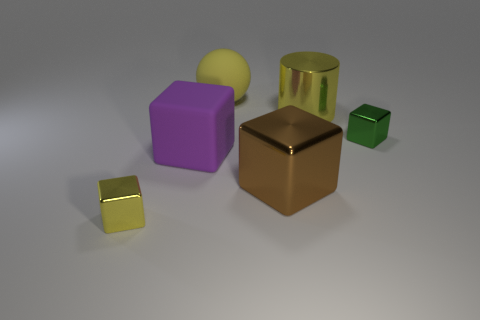What number of things are large yellow things to the right of the yellow ball or rubber objects that are behind the purple block?
Keep it short and to the point. 2. There is a tiny thing on the left side of the big brown metallic thing; does it have the same color as the big shiny cube?
Keep it short and to the point. No. How many other objects are the same color as the rubber sphere?
Provide a short and direct response. 2. What is the brown thing made of?
Offer a very short reply. Metal. There is a shiny thing to the left of the purple cube; does it have the same size as the green thing?
Your response must be concise. Yes. What size is the purple matte object that is the same shape as the brown shiny thing?
Provide a succinct answer. Large. Are there the same number of yellow blocks that are behind the green cube and large purple rubber cubes that are right of the large purple object?
Give a very brief answer. Yes. How big is the metallic cube that is in front of the brown metal cube?
Offer a very short reply. Small. Is the big metallic cylinder the same color as the ball?
Provide a succinct answer. Yes. Is there anything else that has the same shape as the big yellow rubber thing?
Make the answer very short. No. 